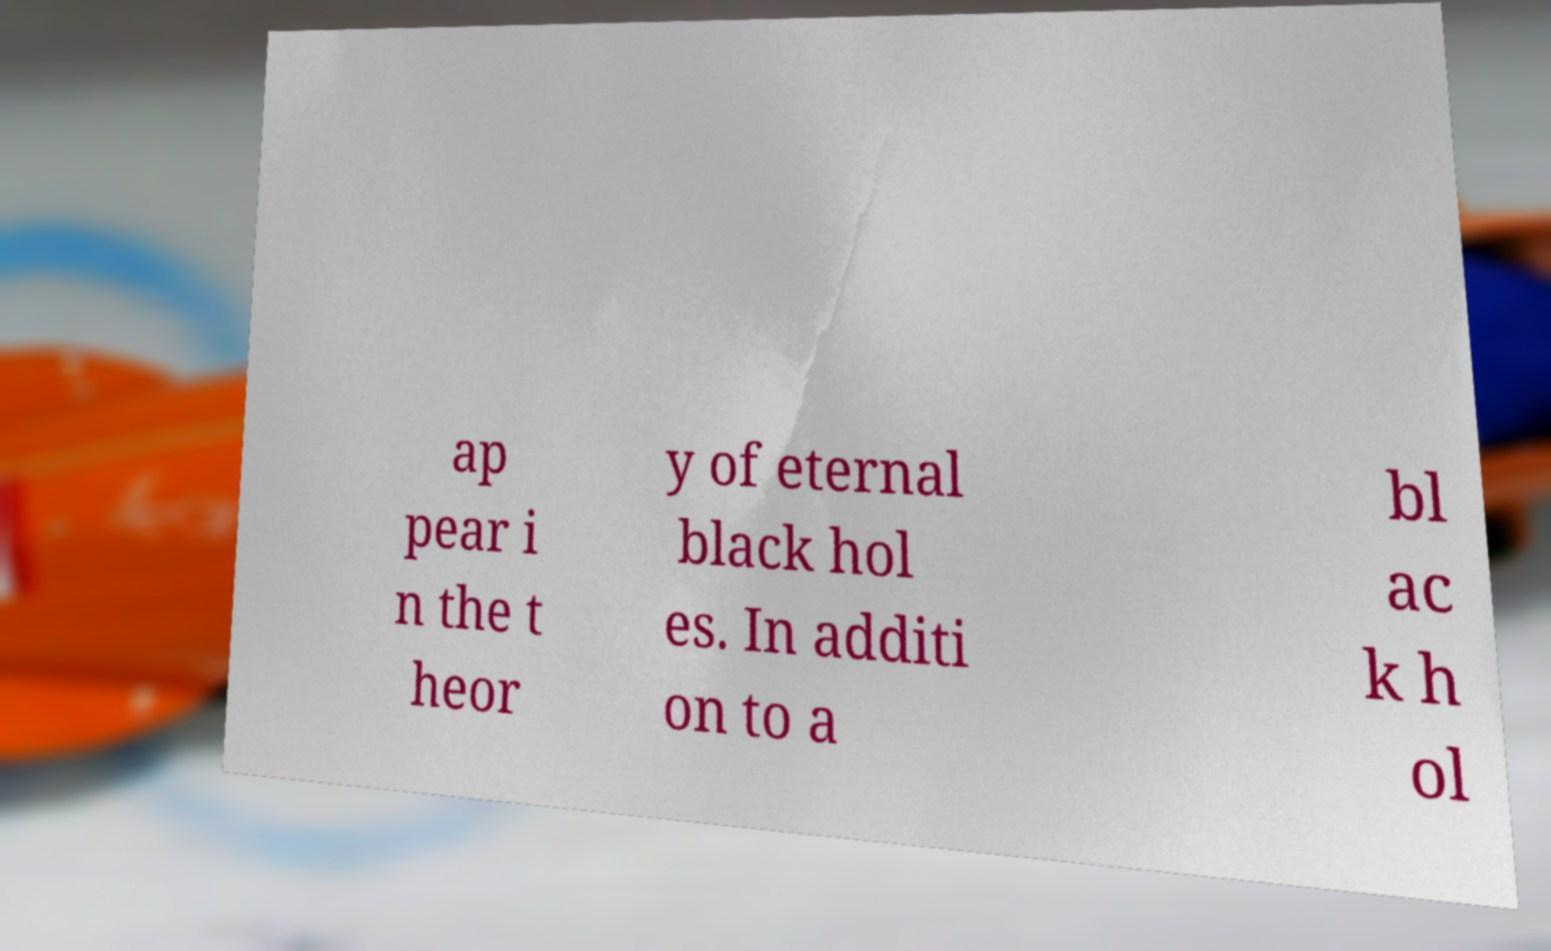What messages or text are displayed in this image? I need them in a readable, typed format. ap pear i n the t heor y of eternal black hol es. In additi on to a bl ac k h ol 